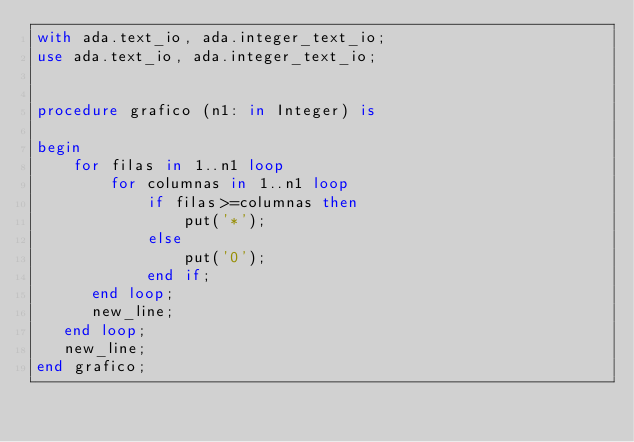<code> <loc_0><loc_0><loc_500><loc_500><_Ada_>with ada.text_io, ada.integer_text_io;
use ada.text_io, ada.integer_text_io;


procedure grafico (n1: in Integer) is

begin
	for filas in 1..n1 loop
		for columnas in 1..n1 loop
			if filas>=columnas then
				put('*');
			else
				put('0');
			end if;
      end loop;
	  new_line;
   end loop;
   new_line;
end grafico;
</code> 